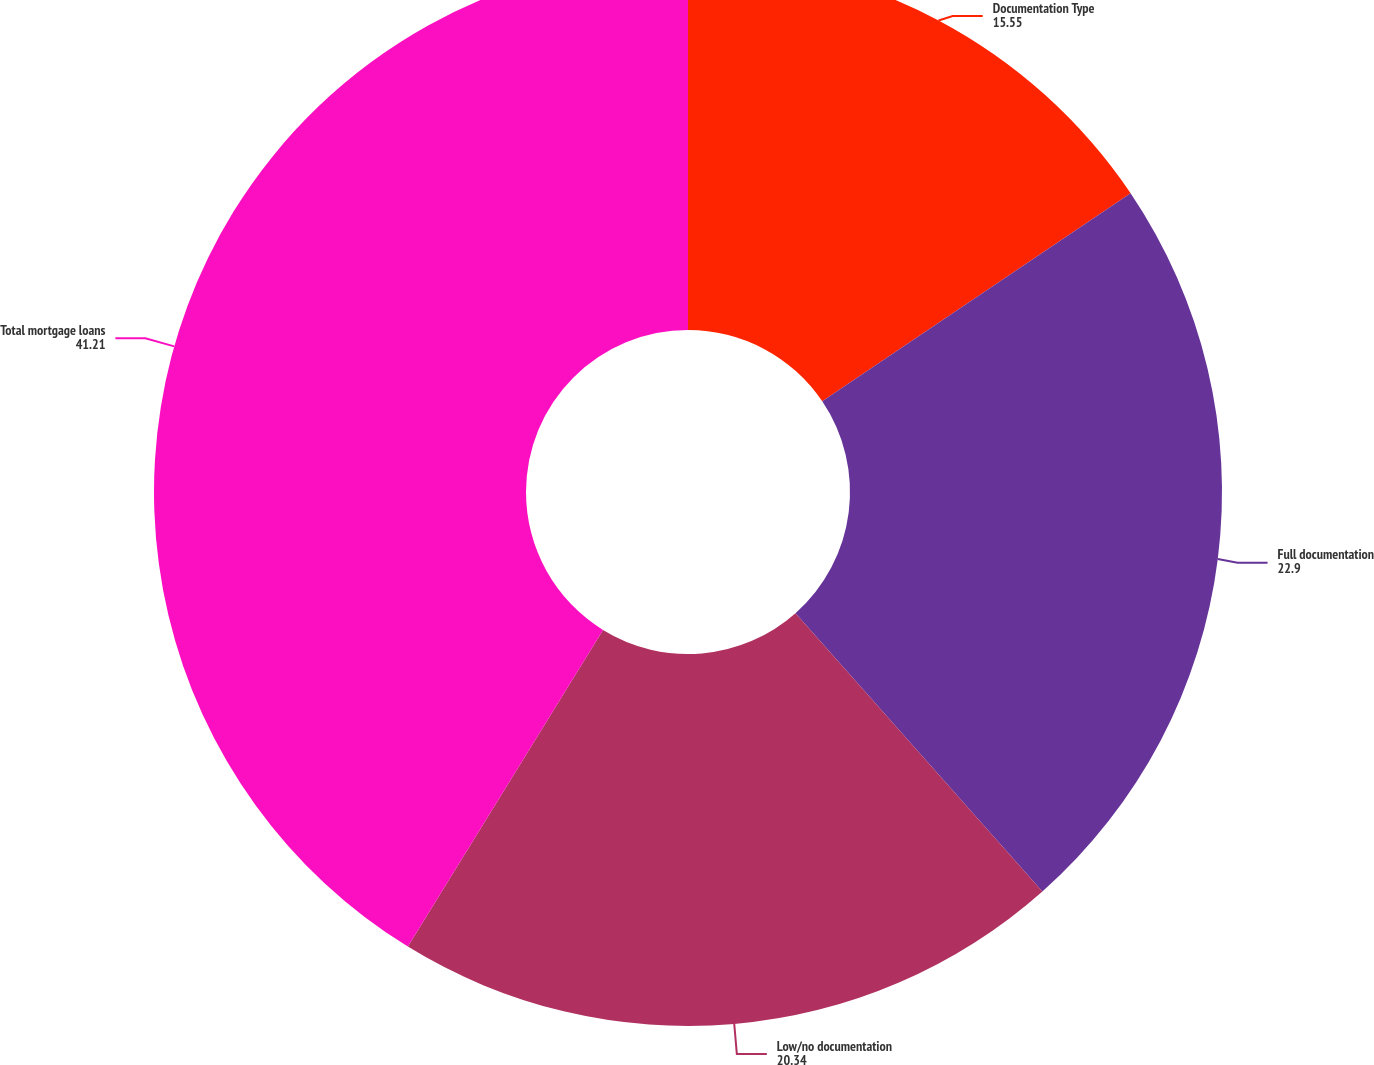Convert chart to OTSL. <chart><loc_0><loc_0><loc_500><loc_500><pie_chart><fcel>Documentation Type<fcel>Full documentation<fcel>Low/no documentation<fcel>Total mortgage loans<nl><fcel>15.55%<fcel>22.9%<fcel>20.34%<fcel>41.21%<nl></chart> 